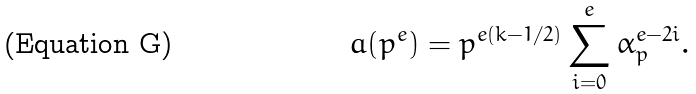Convert formula to latex. <formula><loc_0><loc_0><loc_500><loc_500>a ( p ^ { e } ) = p ^ { e ( k - 1 / 2 ) } \sum _ { i = 0 } ^ { e } \alpha _ { p } ^ { e - 2 i } .</formula> 